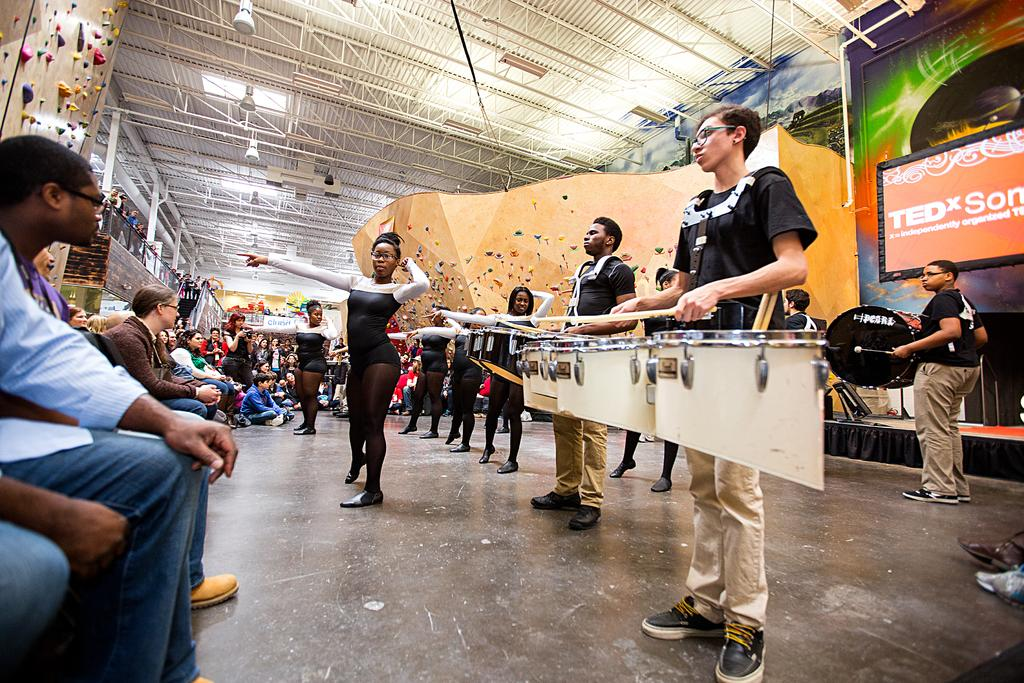What are the people in the image doing? The people in the image are standing and performing. What type of performance is taking place? The performance includes music and dance. Can you describe the audience in the image? In the background, there are people sitting and watching the performance. Is there any quicksand present in the image? No, there is no quicksand present in the image. What suggestion can be made to improve the performance in the image? The provided facts do not allow for a suggestion to be made about improving the performance, as we are only describing what is visible in the image. 